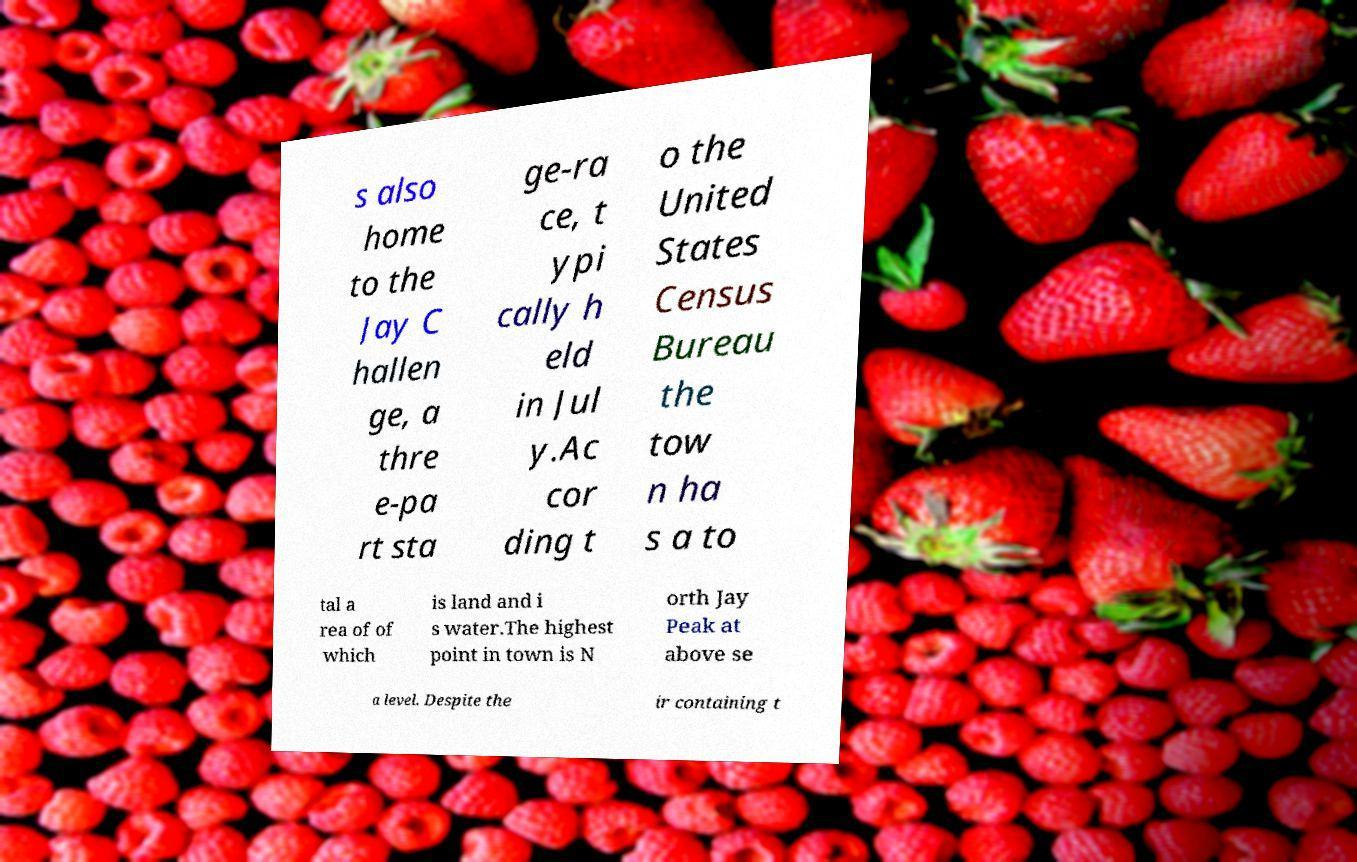There's text embedded in this image that I need extracted. Can you transcribe it verbatim? s also home to the Jay C hallen ge, a thre e-pa rt sta ge-ra ce, t ypi cally h eld in Jul y.Ac cor ding t o the United States Census Bureau the tow n ha s a to tal a rea of of which is land and i s water.The highest point in town is N orth Jay Peak at above se a level. Despite the ir containing t 